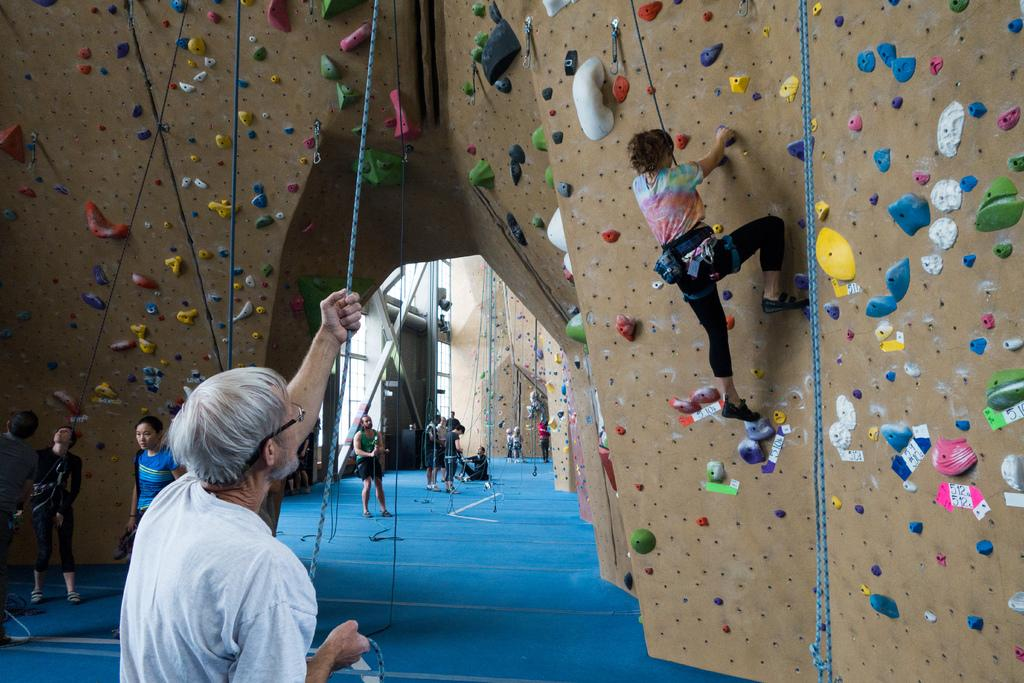What type of activity is being depicted in the image? There are Bouldering walls in the image, which suggests that the activity is related to climbing. What are the people in the image doing? There are people climbing the walls in the image. What might the people holding ropes be doing? The people standing in front of the walls, holding ropes, might be belaying or assisting the climbers. What type of tooth can be seen in the image? There is no tooth present in the image; it features Bouldering walls and people climbing them. What type of berry is being used as a climbing hold in the image? There is no berry present in the image, and the climbing holds are not specified as berries. 